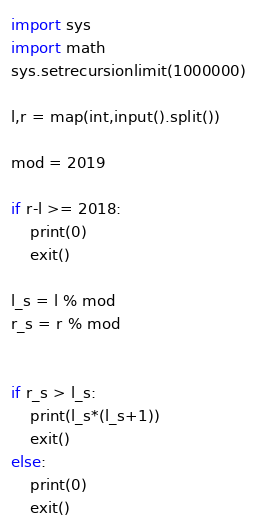<code> <loc_0><loc_0><loc_500><loc_500><_Python_>import sys
import math
sys.setrecursionlimit(1000000)
 
l,r = map(int,input().split())

mod = 2019

if r-l >= 2018:
    print(0)
    exit()
    
l_s = l % mod
r_s = r % mod


if r_s > l_s:
    print(l_s*(l_s+1))
    exit()
else:
    print(0)
    exit()</code> 